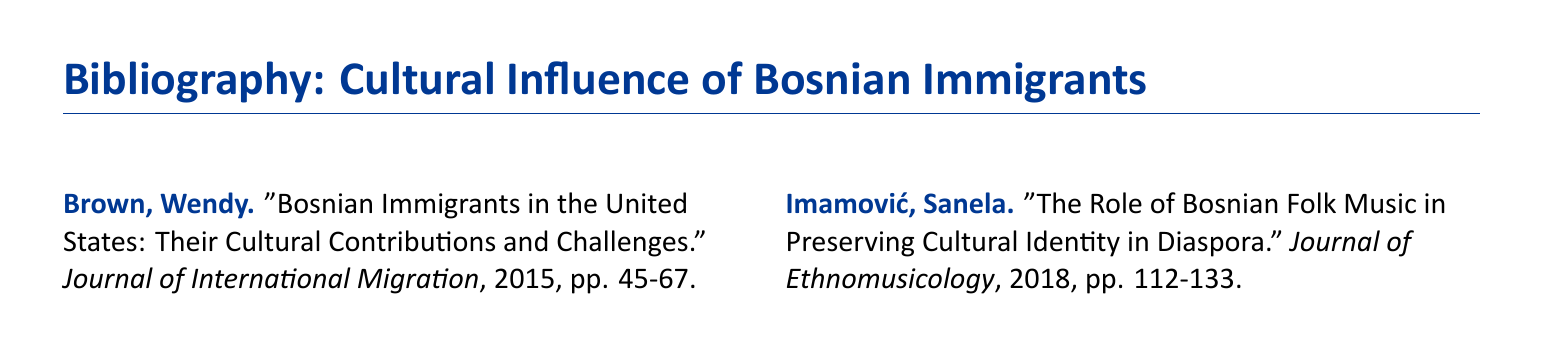What is the title of the document? The title of the document provides a description of its content and is "Bibliography: Cultural Influence of Bosnian Immigrants."
Answer: Bibliography: Cultural Influence of Bosnian Immigrants Who authored the 2015 article about Bosnian immigrants in the United States? The document lists the authors alongside their articles, and the 2015 article is authored by Wendy Brown.
Answer: Wendy Brown In what journal was the article about Bosnian culinary traditions published? The document specifies that Mandić's article is published in the "International Journal of Gastronomy."
Answer: International Journal of Gastronomy What year was the article on Bosnian language schools in Australia published? The bibliography indicates that Mahmutović's article was published in 2019.
Answer: 2019 Which article discusses the influence of Bosnian immigrant artists? The title of the article concerning Bosnian immigrant artists is "Influence of Bosnian Immigrant Artists in Contemporary European Art."
Answer: Influence of Bosnian Immigrant Artists in Contemporary European Art How many articles are listed in this bibliography? The document presents a total of six articles within the bibliography.
Answer: Six What is the color of the text for the authors' names? The document states that the authors' names are formatted in a specific blue color, identified as "bosniablue."
Answer: bosniablue Which journal features the article discussing political identities of Bosnian immigrants? The document indicates that Jovanović's article appears in the "European Journal of Political Science."
Answer: European Journal of Political Science What main theme does the bibliography address? The document outlines that the main theme revolves around the cultural contributions of Bosnian immigrants to multicultural societies.
Answer: Cultural contributions of Bosnian immigrants to multicultural societies 